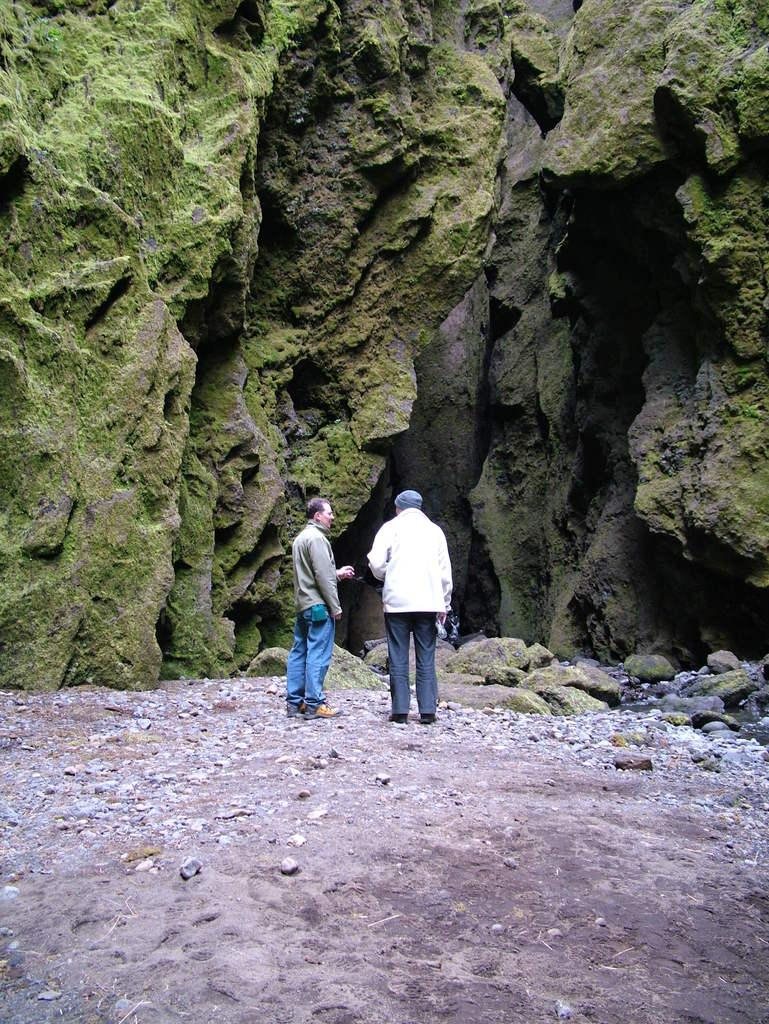How many people are in the image? There are two people standing in the center of the image. What is at the bottom of the image? There is sand and rocks at the bottom of the image. What can be seen in the background of the image? There are mountains in the background of the image. What type of fruit is hanging from the tub in the image? There is no tub or fruit present in the image. Can you see a dog playing with the people in the image? There is no dog present in the image; only the two people are visible. 